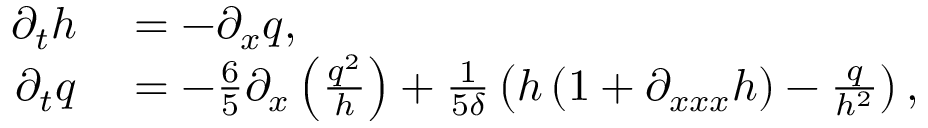<formula> <loc_0><loc_0><loc_500><loc_500>\begin{array} { r l } { \partial _ { t } h } & = - \partial _ { x } q , } \\ { \partial _ { t } q } & = - \frac { 6 } { 5 } \partial _ { x } \left ( \frac { q ^ { 2 } } { h } \right ) + \frac { 1 } { 5 \delta } \left ( h \left ( 1 + \partial _ { x x x } h \right ) - \frac { q } { h ^ { 2 } } \right ) , } \end{array}</formula> 